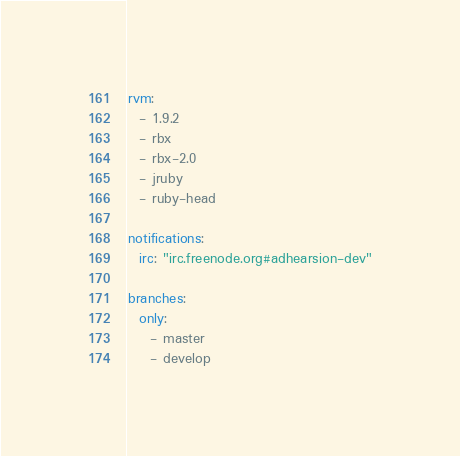<code> <loc_0><loc_0><loc_500><loc_500><_YAML_>rvm:
  - 1.9.2
  - rbx
  - rbx-2.0
  - jruby
  - ruby-head

notifications:
  irc: "irc.freenode.org#adhearsion-dev"

branches:
  only:
    - master
    - develop
</code> 